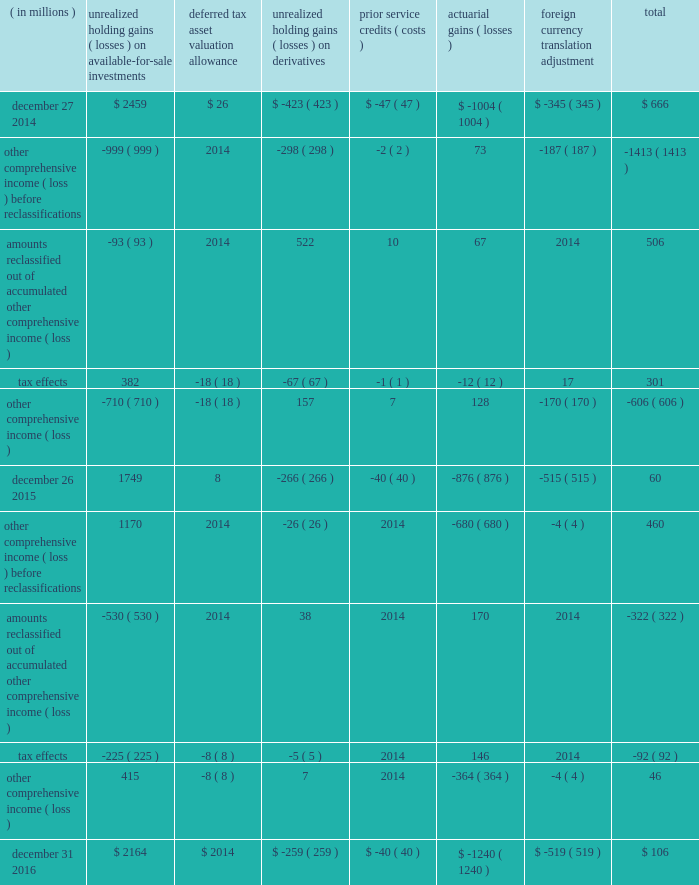Intel corporation notes to consolidated financial statements ( continued ) note 16 : other comprehensive income ( loss ) the changes in accumulated other comprehensive income ( loss ) by component and related tax effects for each period were as follows : ( in millions ) unrealized holding ( losses ) on available- for-sale investments deferred tax asset valuation allowance unrealized holding ( losses ) on derivatives service credits ( costs ) actuarial ( losses ) foreign currency translation adjustment total .

What is the net change in accumulated other comprehensive income during 2015? 
Computations: (60 - 666)
Answer: -606.0. 